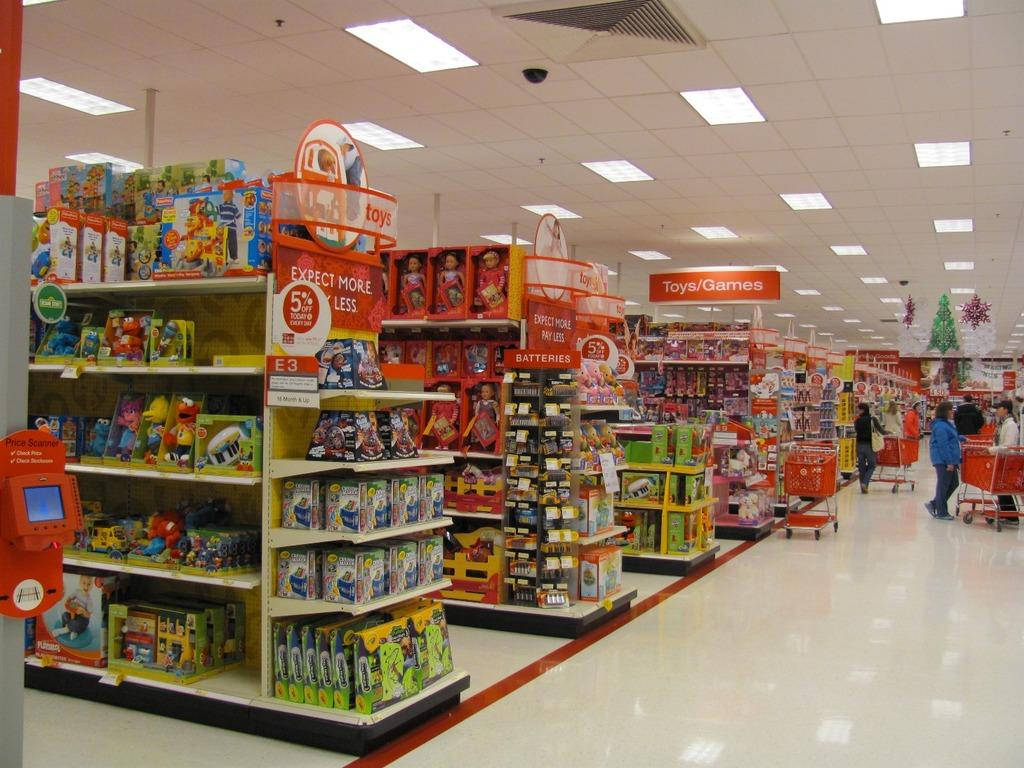<image>
Present a compact description of the photo's key features. A Target store has an "Expect More, Pay Less" sign up in their Toys/Games section 